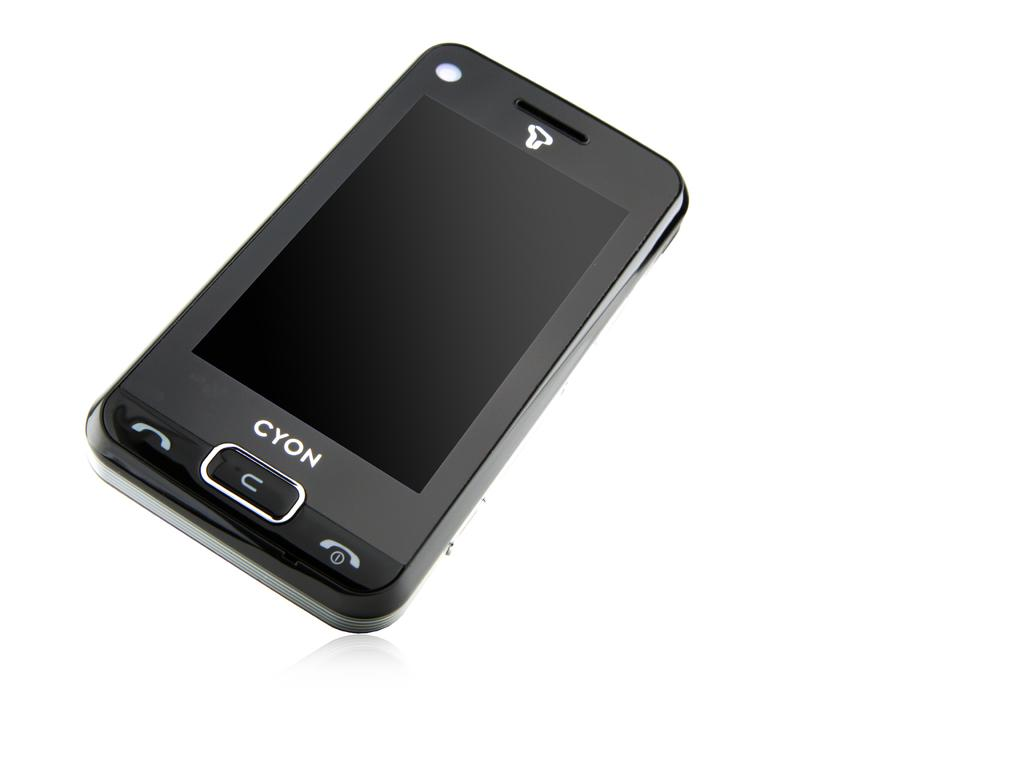<image>
Offer a succinct explanation of the picture presented. a phone with the word cyon written on it 